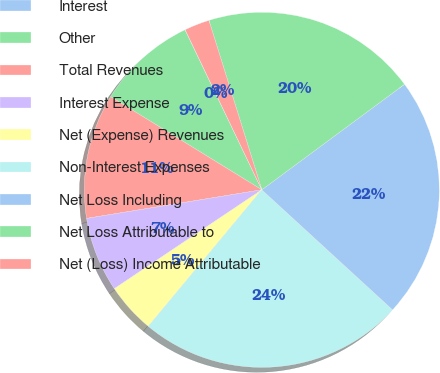Convert chart. <chart><loc_0><loc_0><loc_500><loc_500><pie_chart><fcel>Interest<fcel>Other<fcel>Total Revenues<fcel>Interest Expense<fcel>Net (Expense) Revenues<fcel>Non-Interest Expenses<fcel>Net Loss Including<fcel>Net Loss Attributable to<fcel>Net (Loss) Income Attributable<nl><fcel>0.02%<fcel>9.09%<fcel>11.36%<fcel>6.82%<fcel>4.56%<fcel>24.22%<fcel>21.95%<fcel>19.68%<fcel>2.29%<nl></chart> 